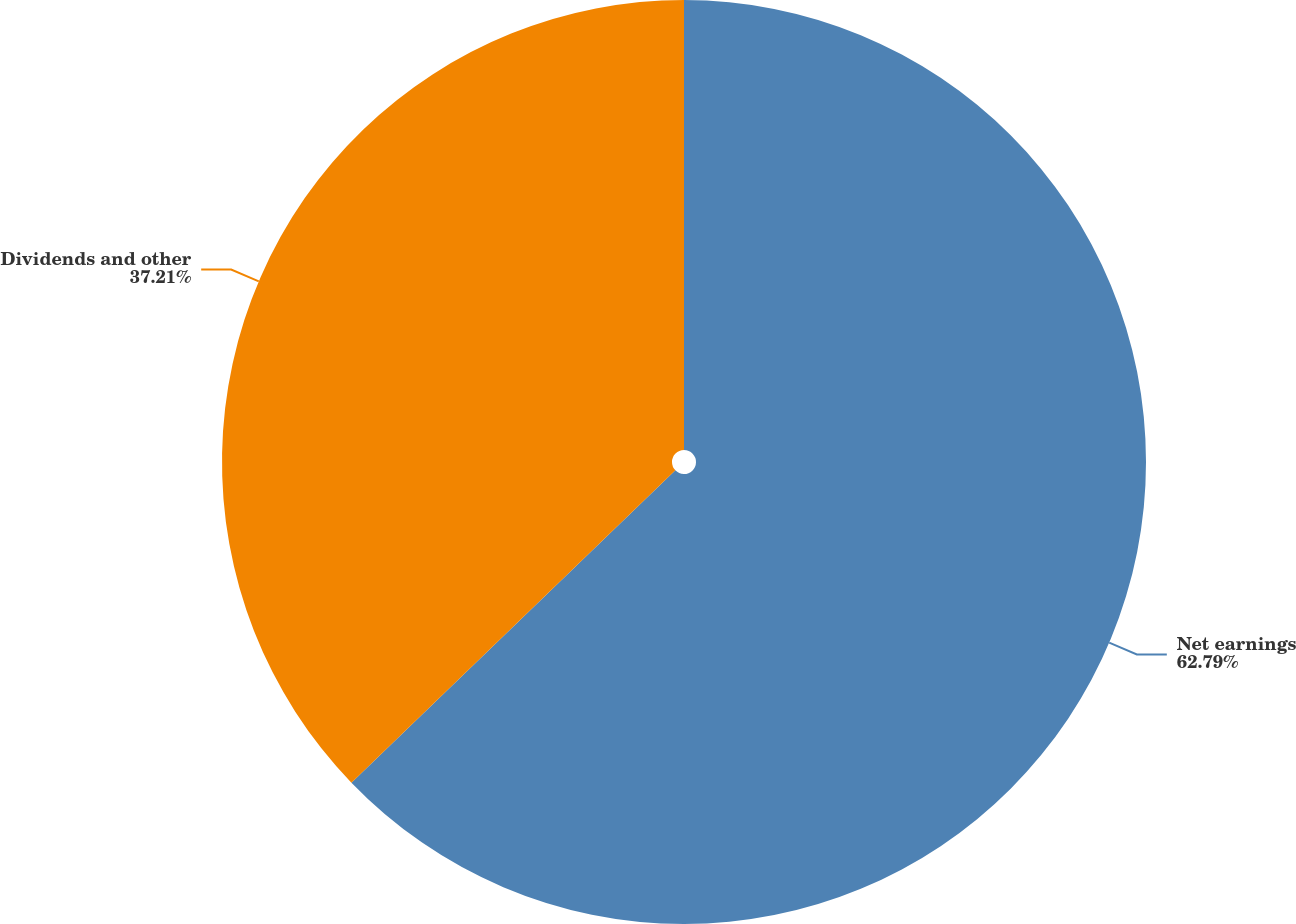Convert chart. <chart><loc_0><loc_0><loc_500><loc_500><pie_chart><fcel>Net earnings<fcel>Dividends and other<nl><fcel>62.79%<fcel>37.21%<nl></chart> 